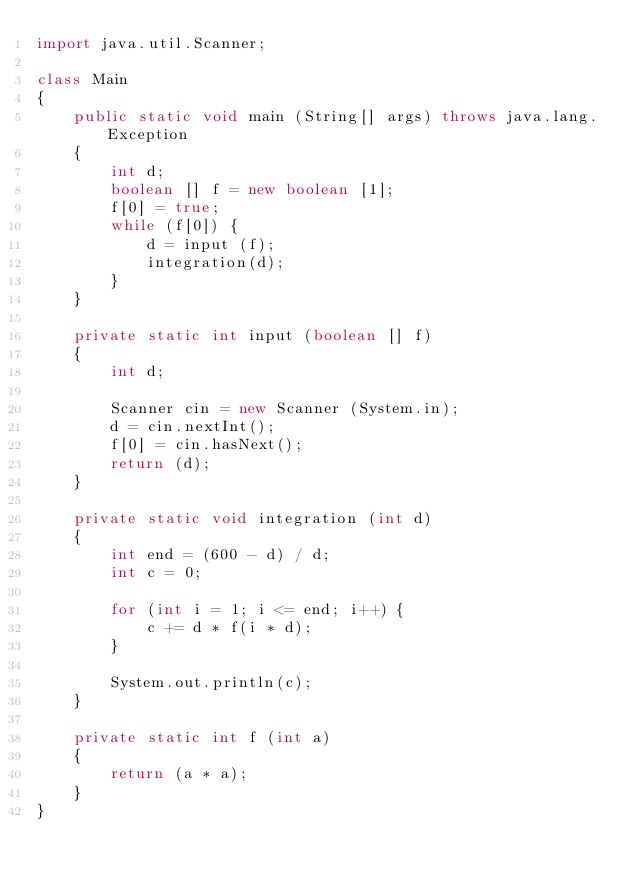<code> <loc_0><loc_0><loc_500><loc_500><_Java_>import java.util.Scanner;

class Main
{
	public static void main (String[] args) throws java.lang.Exception
	{
		int d;
		boolean [] f = new boolean [1];
		f[0] = true;
		while (f[0]) {
			d = input (f);
			integration(d);
		}
	}
	
	private static int input (boolean [] f)
	{
		int d;
		
		Scanner cin = new Scanner (System.in);
		d = cin.nextInt();
		f[0] = cin.hasNext();
		return (d);
	}
	
	private static void integration (int d) 
	{
		int end = (600 - d) / d;
		int c = 0;
		
		for (int i = 1; i <= end; i++) {
			c += d * f(i * d);
		}
		
		System.out.println(c);
	}
	
	private static int f (int a) 
	{
		return (a * a);
	}
}</code> 